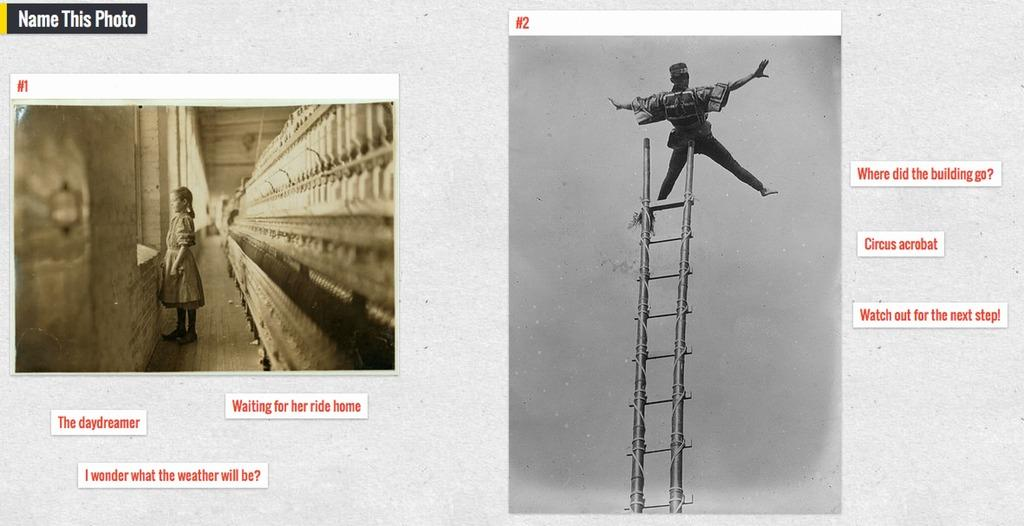<image>
Present a compact description of the photo's key features. A man on a ladder is shown next to red text that says "where did the building go?" 